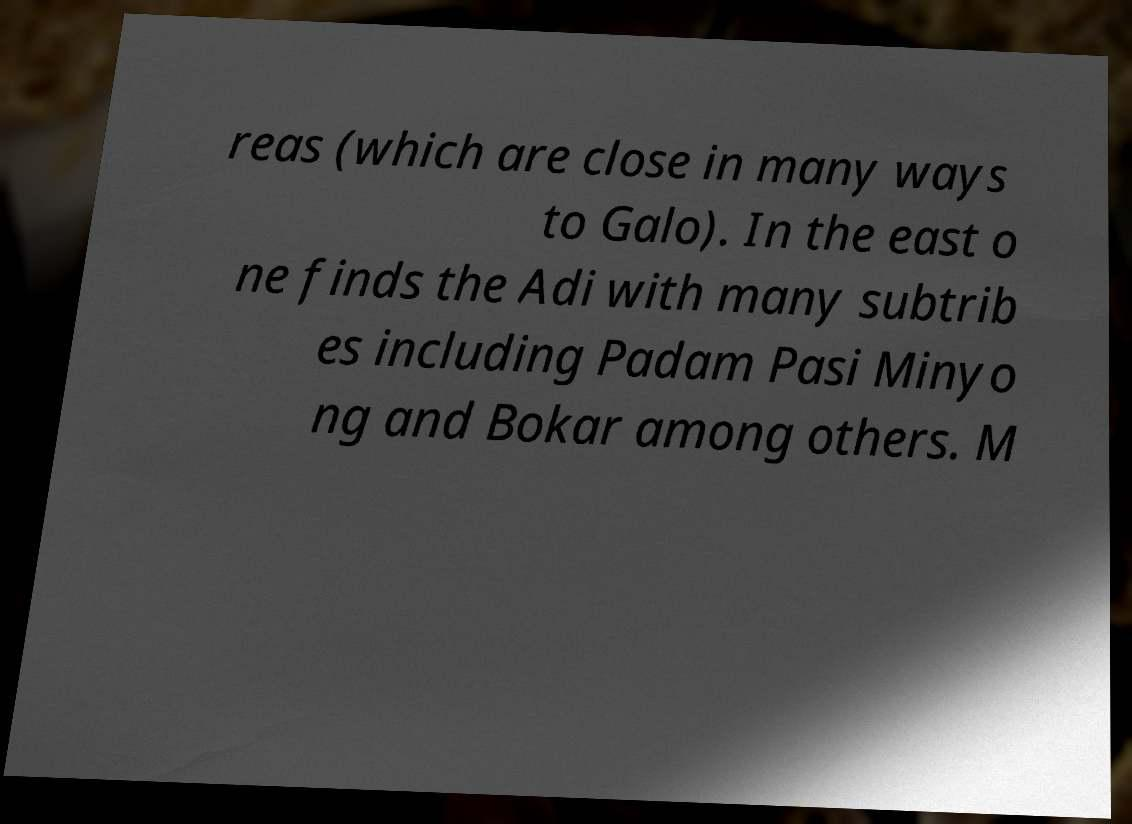I need the written content from this picture converted into text. Can you do that? reas (which are close in many ways to Galo). In the east o ne finds the Adi with many subtrib es including Padam Pasi Minyo ng and Bokar among others. M 